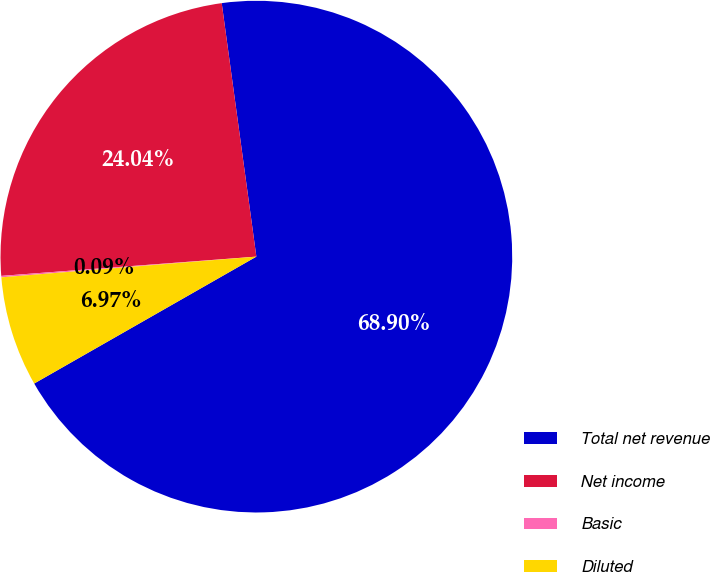<chart> <loc_0><loc_0><loc_500><loc_500><pie_chart><fcel>Total net revenue<fcel>Net income<fcel>Basic<fcel>Diluted<nl><fcel>68.91%<fcel>24.04%<fcel>0.09%<fcel>6.97%<nl></chart> 